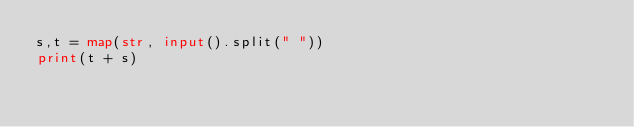Convert code to text. <code><loc_0><loc_0><loc_500><loc_500><_Python_>s,t = map(str, input().split(" "))
print(t + s)</code> 